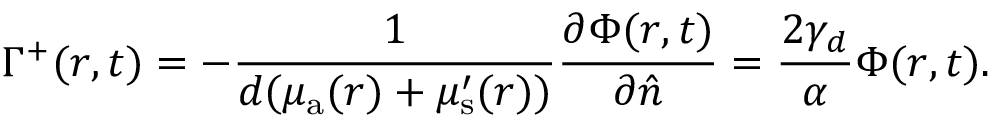<formula> <loc_0><loc_0><loc_500><loc_500>\Gamma ^ { + } ( r , t ) = - \frac { 1 } { { d } ( \mu _ { \mathrm a } ( r ) + \mu _ { s } ^ { \prime } ( r ) ) } \frac { \partial \Phi ( r , t ) } { \partial \hat { n } } = \frac { 2 \gamma _ { d } } { \alpha } \Phi ( r , t ) .</formula> 